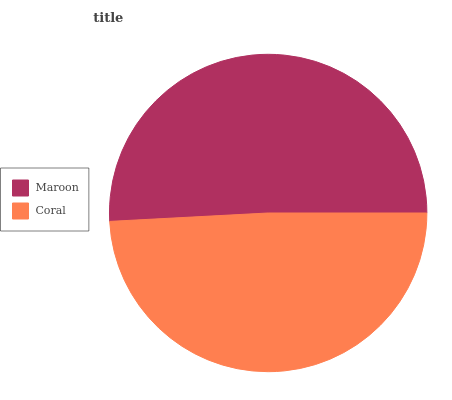Is Coral the minimum?
Answer yes or no. Yes. Is Maroon the maximum?
Answer yes or no. Yes. Is Coral the maximum?
Answer yes or no. No. Is Maroon greater than Coral?
Answer yes or no. Yes. Is Coral less than Maroon?
Answer yes or no. Yes. Is Coral greater than Maroon?
Answer yes or no. No. Is Maroon less than Coral?
Answer yes or no. No. Is Maroon the high median?
Answer yes or no. Yes. Is Coral the low median?
Answer yes or no. Yes. Is Coral the high median?
Answer yes or no. No. Is Maroon the low median?
Answer yes or no. No. 